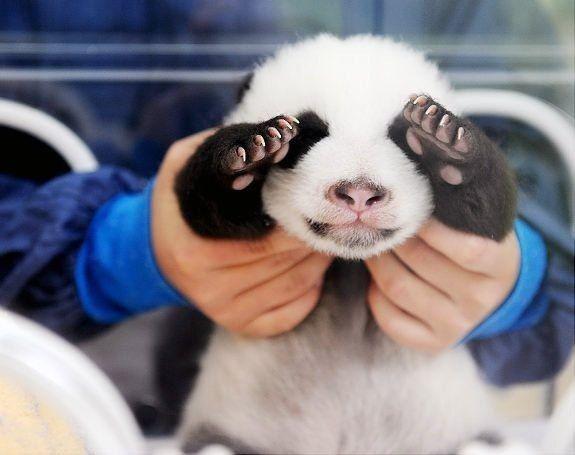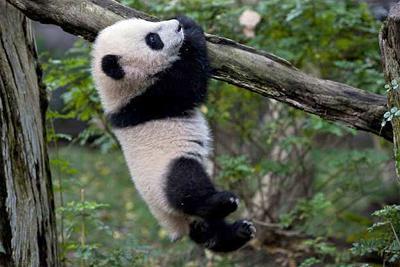The first image is the image on the left, the second image is the image on the right. Considering the images on both sides, is "A panda is hanging on a branch" valid? Answer yes or no. Yes. 